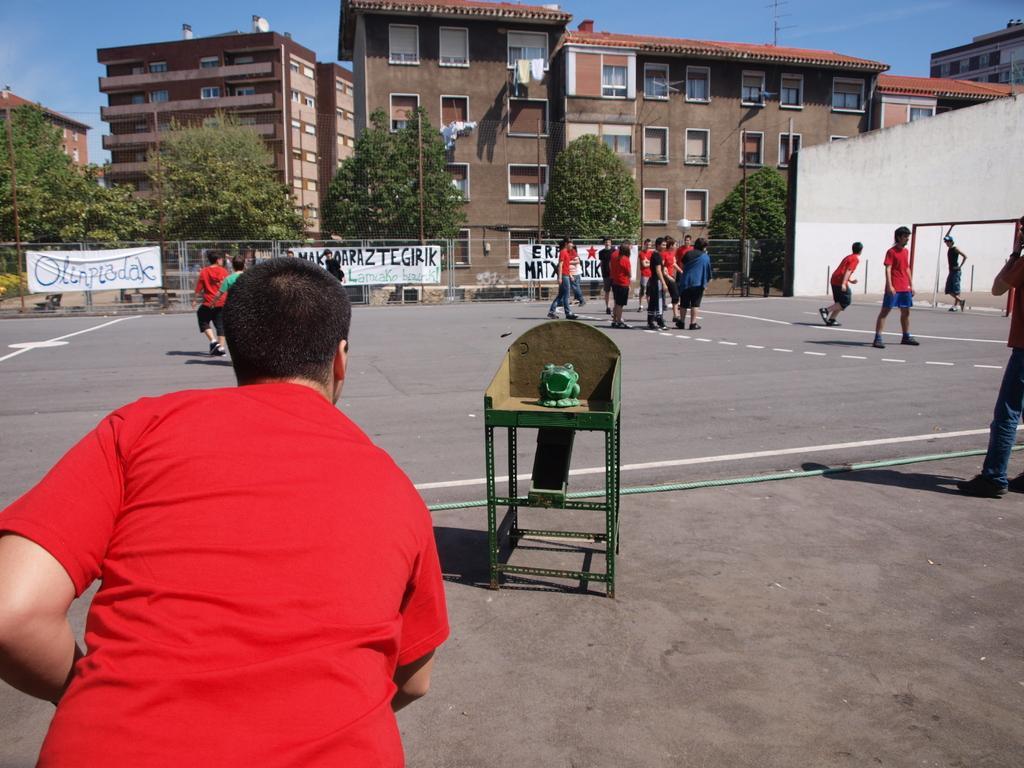Describe this image in one or two sentences. In this image there are buildings, in front of the buildings there are trees, on which there are a few banners with some text are attached, there are a few people standing and walking on the road and there is a wall, in front of the wall there is a metal structure. In the foreground of the image there is a toy on the table and there is a person. In the background there is the sky. 